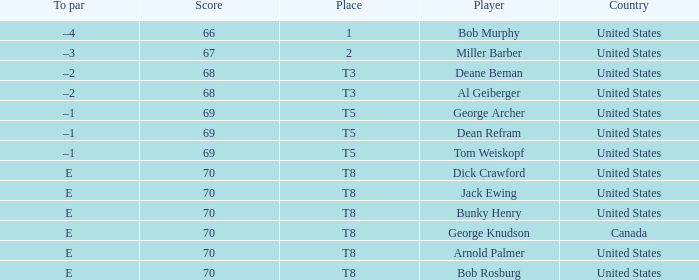Where did Bob Murphy of the United States place? 1.0. 